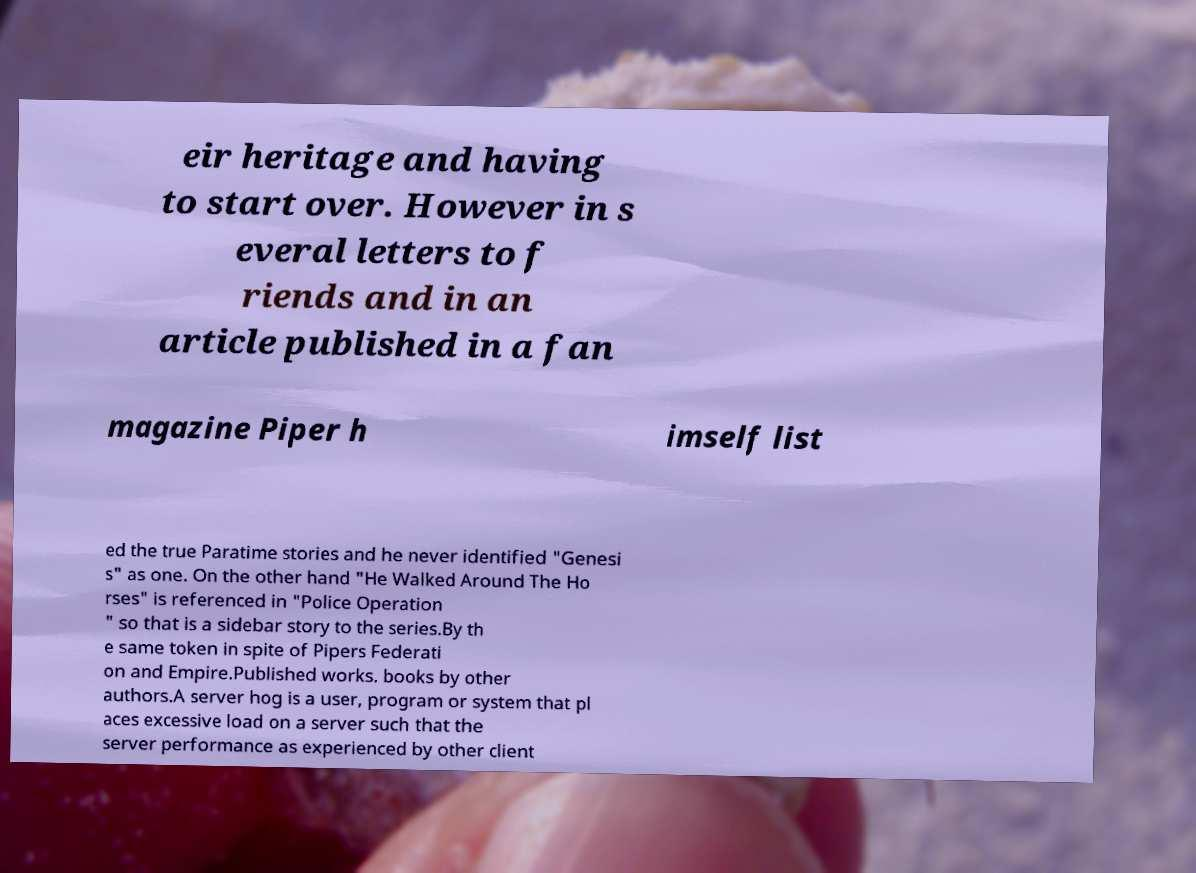Can you read and provide the text displayed in the image?This photo seems to have some interesting text. Can you extract and type it out for me? eir heritage and having to start over. However in s everal letters to f riends and in an article published in a fan magazine Piper h imself list ed the true Paratime stories and he never identified "Genesi s" as one. On the other hand "He Walked Around The Ho rses" is referenced in "Police Operation " so that is a sidebar story to the series.By th e same token in spite of Pipers Federati on and Empire.Published works. books by other authors.A server hog is a user, program or system that pl aces excessive load on a server such that the server performance as experienced by other client 